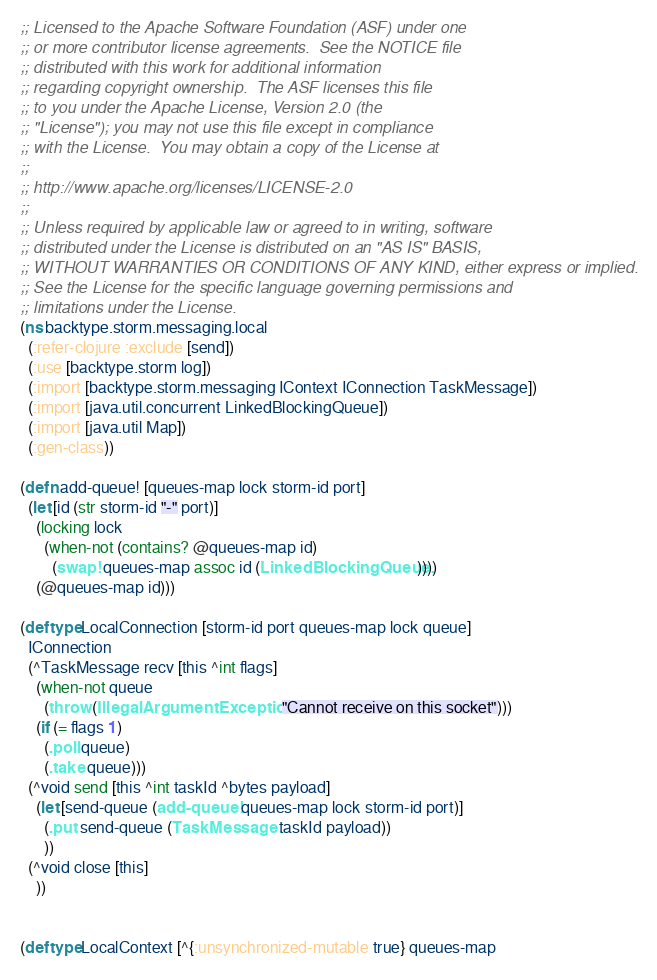<code> <loc_0><loc_0><loc_500><loc_500><_Clojure_>;; Licensed to the Apache Software Foundation (ASF) under one
;; or more contributor license agreements.  See the NOTICE file
;; distributed with this work for additional information
;; regarding copyright ownership.  The ASF licenses this file
;; to you under the Apache License, Version 2.0 (the
;; "License"); you may not use this file except in compliance
;; with the License.  You may obtain a copy of the License at
;;
;; http://www.apache.org/licenses/LICENSE-2.0
;;
;; Unless required by applicable law or agreed to in writing, software
;; distributed under the License is distributed on an "AS IS" BASIS,
;; WITHOUT WARRANTIES OR CONDITIONS OF ANY KIND, either express or implied.
;; See the License for the specific language governing permissions and
;; limitations under the License.
(ns backtype.storm.messaging.local
  (:refer-clojure :exclude [send])
  (:use [backtype.storm log])
  (:import [backtype.storm.messaging IContext IConnection TaskMessage])
  (:import [java.util.concurrent LinkedBlockingQueue])
  (:import [java.util Map])
  (:gen-class))

(defn add-queue! [queues-map lock storm-id port]
  (let [id (str storm-id "-" port)]
    (locking lock
      (when-not (contains? @queues-map id)
        (swap! queues-map assoc id (LinkedBlockingQueue.))))
    (@queues-map id)))

(deftype LocalConnection [storm-id port queues-map lock queue]
  IConnection
  (^TaskMessage recv [this ^int flags]
    (when-not queue
      (throw (IllegalArgumentException. "Cannot receive on this socket")))
    (if (= flags 1)
      (.poll queue)
      (.take queue)))
  (^void send [this ^int taskId ^bytes payload]
    (let [send-queue (add-queue! queues-map lock storm-id port)]
      (.put send-queue (TaskMessage. taskId payload))
      ))
  (^void close [this]
    ))


(deftype LocalContext [^{:unsynchronized-mutable true} queues-map</code> 